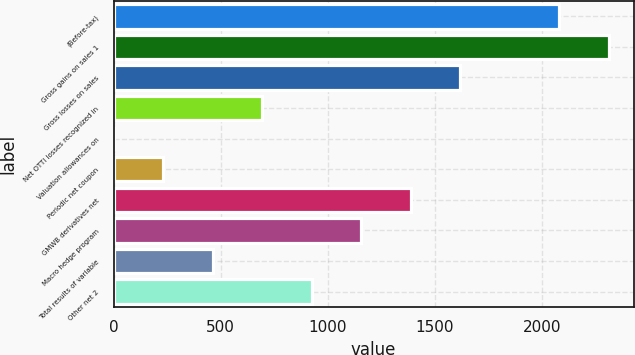Convert chart to OTSL. <chart><loc_0><loc_0><loc_500><loc_500><bar_chart><fcel>(Before-tax)<fcel>Gross gains on sales 1<fcel>Gross losses on sales<fcel>Net OTTI losses recognized in<fcel>Valuation allowances on<fcel>Periodic net coupon<fcel>GMWB derivatives net<fcel>Macro hedge program<fcel>Total results of variable<fcel>Other net 2<nl><fcel>2081.8<fcel>2313<fcel>1619.4<fcel>694.6<fcel>1<fcel>232.2<fcel>1388.2<fcel>1157<fcel>463.4<fcel>925.8<nl></chart> 